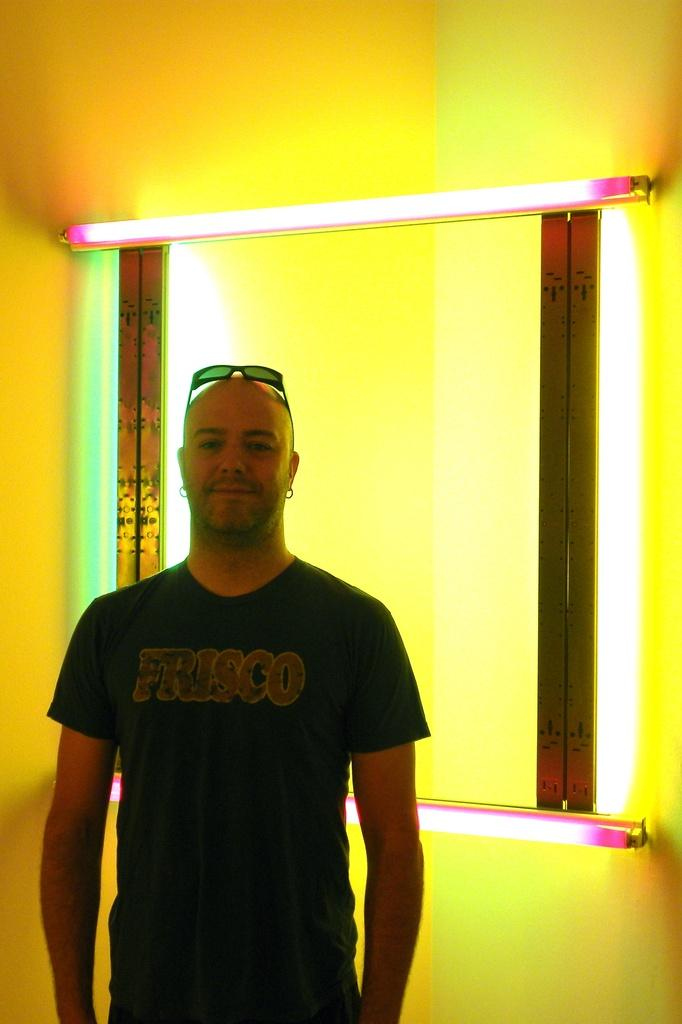What is the position of the man in the image? The man is standing on the left side of the image. What can be seen in the background of the image? There is a wall and a window in the background of the image. What type of furniture is present on the stage in the image? There is no stage or furniture present in the image; it only features a man standing on the left side and a wall with a window in the background. 